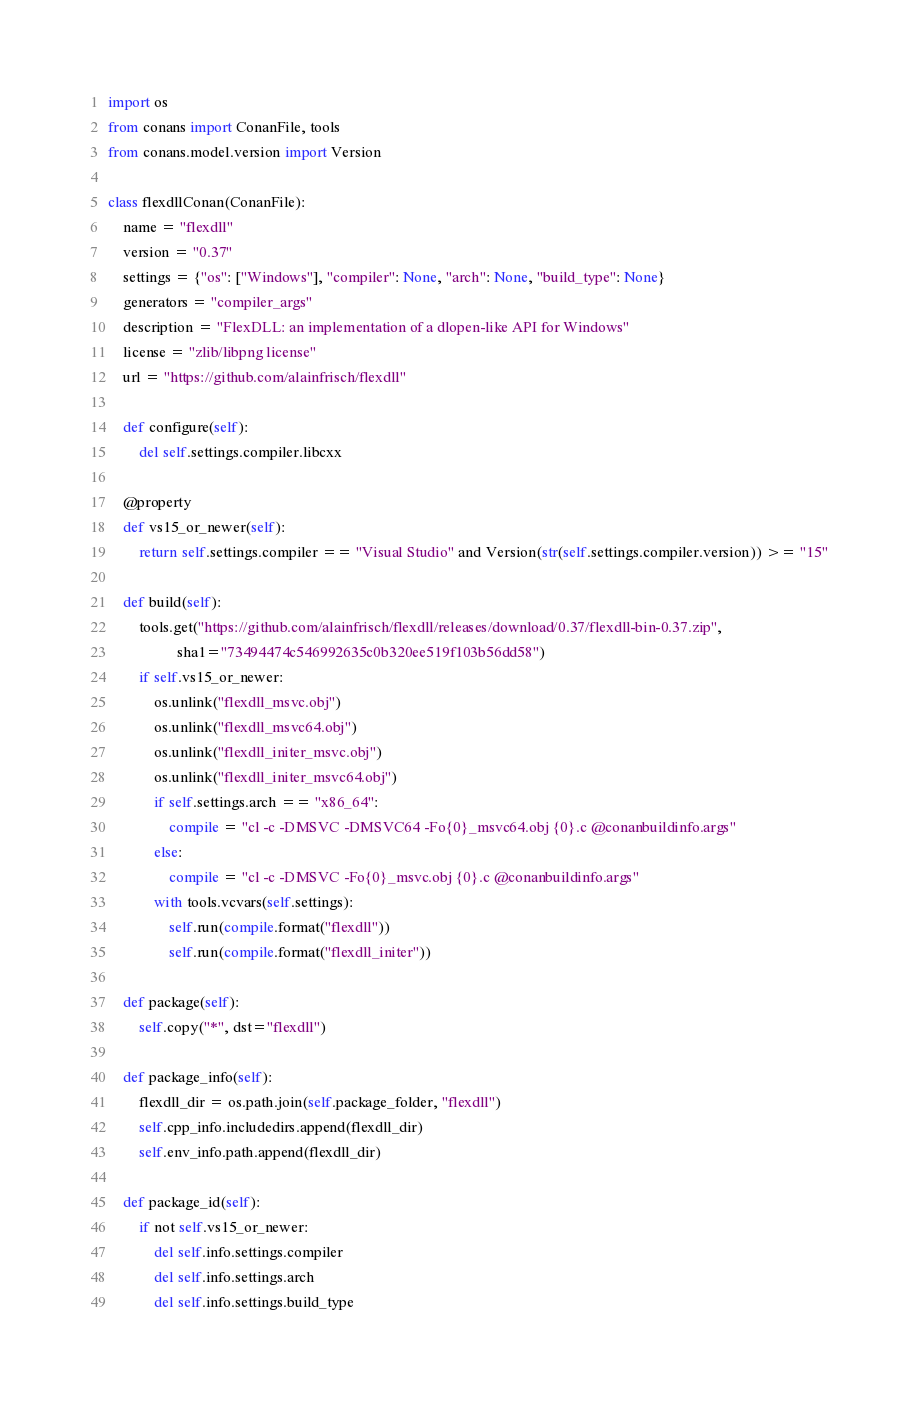<code> <loc_0><loc_0><loc_500><loc_500><_Python_>import os
from conans import ConanFile, tools
from conans.model.version import Version

class flexdllConan(ConanFile):
    name = "flexdll"
    version = "0.37"
    settings = {"os": ["Windows"], "compiler": None, "arch": None, "build_type": None}
    generators = "compiler_args"
    description = "FlexDLL: an implementation of a dlopen-like API for Windows"
    license = "zlib/libpng license"
    url = "https://github.com/alainfrisch/flexdll"

    def configure(self):
        del self.settings.compiler.libcxx

    @property
    def vs15_or_newer(self):
        return self.settings.compiler == "Visual Studio" and Version(str(self.settings.compiler.version)) >= "15"

    def build(self):
        tools.get("https://github.com/alainfrisch/flexdll/releases/download/0.37/flexdll-bin-0.37.zip",
                  sha1="73494474c546992635c0b320ee519f103b56dd58")
        if self.vs15_or_newer:
            os.unlink("flexdll_msvc.obj")
            os.unlink("flexdll_msvc64.obj")
            os.unlink("flexdll_initer_msvc.obj")
            os.unlink("flexdll_initer_msvc64.obj")
            if self.settings.arch == "x86_64":
                compile = "cl -c -DMSVC -DMSVC64 -Fo{0}_msvc64.obj {0}.c @conanbuildinfo.args"
            else:
                compile = "cl -c -DMSVC -Fo{0}_msvc.obj {0}.c @conanbuildinfo.args"
            with tools.vcvars(self.settings):
                self.run(compile.format("flexdll"))
                self.run(compile.format("flexdll_initer"))

    def package(self):
        self.copy("*", dst="flexdll")

    def package_info(self):
        flexdll_dir = os.path.join(self.package_folder, "flexdll")
        self.cpp_info.includedirs.append(flexdll_dir)
        self.env_info.path.append(flexdll_dir)

    def package_id(self):
        if not self.vs15_or_newer:
            del self.info.settings.compiler
            del self.info.settings.arch
            del self.info.settings.build_type
</code> 